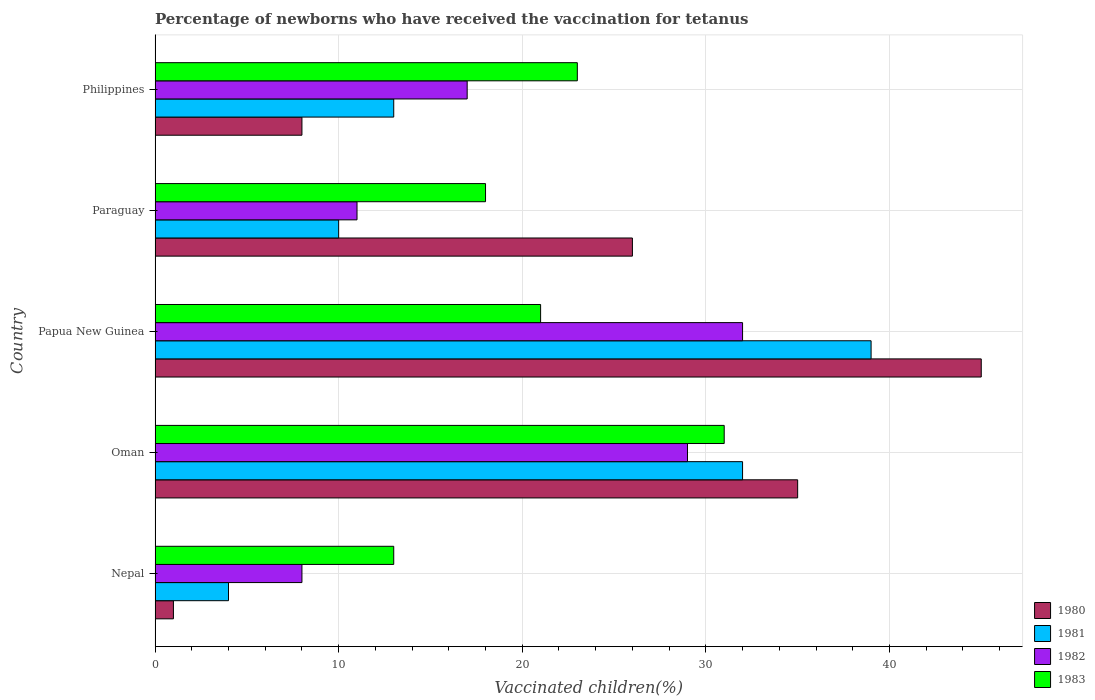How many different coloured bars are there?
Your response must be concise. 4. How many groups of bars are there?
Keep it short and to the point. 5. Are the number of bars per tick equal to the number of legend labels?
Offer a very short reply. Yes. How many bars are there on the 4th tick from the top?
Make the answer very short. 4. How many bars are there on the 3rd tick from the bottom?
Your answer should be very brief. 4. What is the label of the 4th group of bars from the top?
Give a very brief answer. Oman. Across all countries, what is the maximum percentage of vaccinated children in 1980?
Your answer should be compact. 45. In which country was the percentage of vaccinated children in 1982 maximum?
Offer a very short reply. Papua New Guinea. In which country was the percentage of vaccinated children in 1980 minimum?
Ensure brevity in your answer.  Nepal. What is the total percentage of vaccinated children in 1981 in the graph?
Offer a terse response. 98. What is the difference between the percentage of vaccinated children in 1980 in Paraguay and the percentage of vaccinated children in 1982 in Philippines?
Provide a succinct answer. 9. What is the average percentage of vaccinated children in 1980 per country?
Keep it short and to the point. 23. In how many countries, is the percentage of vaccinated children in 1983 greater than 32 %?
Your response must be concise. 0. Is the percentage of vaccinated children in 1980 in Papua New Guinea less than that in Paraguay?
Your answer should be compact. No. Is the difference between the percentage of vaccinated children in 1983 in Oman and Paraguay greater than the difference between the percentage of vaccinated children in 1981 in Oman and Paraguay?
Make the answer very short. No. In how many countries, is the percentage of vaccinated children in 1980 greater than the average percentage of vaccinated children in 1980 taken over all countries?
Provide a succinct answer. 3. Is the sum of the percentage of vaccinated children in 1982 in Nepal and Papua New Guinea greater than the maximum percentage of vaccinated children in 1980 across all countries?
Your answer should be compact. No. Is it the case that in every country, the sum of the percentage of vaccinated children in 1982 and percentage of vaccinated children in 1980 is greater than the sum of percentage of vaccinated children in 1983 and percentage of vaccinated children in 1981?
Your answer should be compact. No. What does the 4th bar from the top in Nepal represents?
Provide a succinct answer. 1980. How many bars are there?
Offer a terse response. 20. How many countries are there in the graph?
Provide a succinct answer. 5. What is the difference between two consecutive major ticks on the X-axis?
Give a very brief answer. 10. Does the graph contain grids?
Make the answer very short. Yes. Where does the legend appear in the graph?
Make the answer very short. Bottom right. What is the title of the graph?
Your answer should be compact. Percentage of newborns who have received the vaccination for tetanus. What is the label or title of the X-axis?
Your response must be concise. Vaccinated children(%). What is the Vaccinated children(%) in 1981 in Nepal?
Offer a very short reply. 4. What is the Vaccinated children(%) of 1982 in Nepal?
Give a very brief answer. 8. What is the Vaccinated children(%) in 1980 in Oman?
Your response must be concise. 35. What is the Vaccinated children(%) in 1982 in Oman?
Your response must be concise. 29. What is the Vaccinated children(%) of 1983 in Oman?
Your response must be concise. 31. What is the Vaccinated children(%) in 1980 in Papua New Guinea?
Your answer should be very brief. 45. What is the Vaccinated children(%) in 1983 in Papua New Guinea?
Provide a succinct answer. 21. What is the Vaccinated children(%) in 1980 in Paraguay?
Give a very brief answer. 26. What is the Vaccinated children(%) of 1982 in Paraguay?
Ensure brevity in your answer.  11. What is the Vaccinated children(%) of 1983 in Paraguay?
Give a very brief answer. 18. What is the Vaccinated children(%) in 1981 in Philippines?
Your answer should be very brief. 13. Across all countries, what is the maximum Vaccinated children(%) of 1980?
Offer a very short reply. 45. Across all countries, what is the maximum Vaccinated children(%) of 1981?
Your answer should be compact. 39. Across all countries, what is the maximum Vaccinated children(%) of 1982?
Keep it short and to the point. 32. Across all countries, what is the maximum Vaccinated children(%) in 1983?
Offer a terse response. 31. Across all countries, what is the minimum Vaccinated children(%) in 1981?
Keep it short and to the point. 4. Across all countries, what is the minimum Vaccinated children(%) in 1983?
Provide a succinct answer. 13. What is the total Vaccinated children(%) of 1980 in the graph?
Offer a very short reply. 115. What is the total Vaccinated children(%) in 1981 in the graph?
Provide a short and direct response. 98. What is the total Vaccinated children(%) in 1982 in the graph?
Provide a succinct answer. 97. What is the total Vaccinated children(%) in 1983 in the graph?
Your answer should be very brief. 106. What is the difference between the Vaccinated children(%) in 1980 in Nepal and that in Oman?
Offer a very short reply. -34. What is the difference between the Vaccinated children(%) of 1981 in Nepal and that in Oman?
Your answer should be very brief. -28. What is the difference between the Vaccinated children(%) in 1980 in Nepal and that in Papua New Guinea?
Your response must be concise. -44. What is the difference between the Vaccinated children(%) in 1981 in Nepal and that in Papua New Guinea?
Provide a succinct answer. -35. What is the difference between the Vaccinated children(%) in 1981 in Nepal and that in Paraguay?
Keep it short and to the point. -6. What is the difference between the Vaccinated children(%) of 1980 in Nepal and that in Philippines?
Make the answer very short. -7. What is the difference between the Vaccinated children(%) in 1981 in Nepal and that in Philippines?
Offer a terse response. -9. What is the difference between the Vaccinated children(%) in 1982 in Nepal and that in Philippines?
Offer a very short reply. -9. What is the difference between the Vaccinated children(%) in 1983 in Nepal and that in Philippines?
Your answer should be compact. -10. What is the difference between the Vaccinated children(%) of 1980 in Oman and that in Papua New Guinea?
Provide a short and direct response. -10. What is the difference between the Vaccinated children(%) of 1981 in Oman and that in Paraguay?
Keep it short and to the point. 22. What is the difference between the Vaccinated children(%) of 1982 in Oman and that in Paraguay?
Provide a succinct answer. 18. What is the difference between the Vaccinated children(%) in 1983 in Oman and that in Philippines?
Your answer should be very brief. 8. What is the difference between the Vaccinated children(%) of 1983 in Papua New Guinea and that in Paraguay?
Offer a terse response. 3. What is the difference between the Vaccinated children(%) of 1982 in Papua New Guinea and that in Philippines?
Your response must be concise. 15. What is the difference between the Vaccinated children(%) of 1982 in Paraguay and that in Philippines?
Your response must be concise. -6. What is the difference between the Vaccinated children(%) of 1983 in Paraguay and that in Philippines?
Your response must be concise. -5. What is the difference between the Vaccinated children(%) in 1980 in Nepal and the Vaccinated children(%) in 1981 in Oman?
Provide a short and direct response. -31. What is the difference between the Vaccinated children(%) in 1980 in Nepal and the Vaccinated children(%) in 1982 in Oman?
Give a very brief answer. -28. What is the difference between the Vaccinated children(%) of 1980 in Nepal and the Vaccinated children(%) of 1981 in Papua New Guinea?
Make the answer very short. -38. What is the difference between the Vaccinated children(%) of 1980 in Nepal and the Vaccinated children(%) of 1982 in Papua New Guinea?
Your response must be concise. -31. What is the difference between the Vaccinated children(%) of 1980 in Nepal and the Vaccinated children(%) of 1983 in Papua New Guinea?
Your response must be concise. -20. What is the difference between the Vaccinated children(%) in 1981 in Nepal and the Vaccinated children(%) in 1983 in Papua New Guinea?
Keep it short and to the point. -17. What is the difference between the Vaccinated children(%) of 1982 in Nepal and the Vaccinated children(%) of 1983 in Papua New Guinea?
Your answer should be compact. -13. What is the difference between the Vaccinated children(%) in 1980 in Nepal and the Vaccinated children(%) in 1983 in Paraguay?
Provide a short and direct response. -17. What is the difference between the Vaccinated children(%) in 1981 in Nepal and the Vaccinated children(%) in 1982 in Paraguay?
Your response must be concise. -7. What is the difference between the Vaccinated children(%) in 1981 in Nepal and the Vaccinated children(%) in 1983 in Paraguay?
Keep it short and to the point. -14. What is the difference between the Vaccinated children(%) of 1980 in Nepal and the Vaccinated children(%) of 1981 in Philippines?
Keep it short and to the point. -12. What is the difference between the Vaccinated children(%) of 1980 in Nepal and the Vaccinated children(%) of 1982 in Philippines?
Make the answer very short. -16. What is the difference between the Vaccinated children(%) in 1980 in Oman and the Vaccinated children(%) in 1981 in Papua New Guinea?
Give a very brief answer. -4. What is the difference between the Vaccinated children(%) in 1980 in Oman and the Vaccinated children(%) in 1982 in Papua New Guinea?
Make the answer very short. 3. What is the difference between the Vaccinated children(%) of 1980 in Oman and the Vaccinated children(%) of 1983 in Papua New Guinea?
Ensure brevity in your answer.  14. What is the difference between the Vaccinated children(%) in 1981 in Oman and the Vaccinated children(%) in 1983 in Papua New Guinea?
Your answer should be compact. 11. What is the difference between the Vaccinated children(%) of 1982 in Oman and the Vaccinated children(%) of 1983 in Papua New Guinea?
Make the answer very short. 8. What is the difference between the Vaccinated children(%) in 1981 in Oman and the Vaccinated children(%) in 1983 in Paraguay?
Offer a very short reply. 14. What is the difference between the Vaccinated children(%) in 1982 in Oman and the Vaccinated children(%) in 1983 in Paraguay?
Provide a succinct answer. 11. What is the difference between the Vaccinated children(%) of 1980 in Oman and the Vaccinated children(%) of 1981 in Philippines?
Your answer should be very brief. 22. What is the difference between the Vaccinated children(%) of 1980 in Oman and the Vaccinated children(%) of 1982 in Philippines?
Your answer should be very brief. 18. What is the difference between the Vaccinated children(%) in 1980 in Oman and the Vaccinated children(%) in 1983 in Philippines?
Offer a very short reply. 12. What is the difference between the Vaccinated children(%) in 1981 in Oman and the Vaccinated children(%) in 1982 in Philippines?
Provide a succinct answer. 15. What is the difference between the Vaccinated children(%) of 1982 in Oman and the Vaccinated children(%) of 1983 in Philippines?
Make the answer very short. 6. What is the difference between the Vaccinated children(%) in 1980 in Papua New Guinea and the Vaccinated children(%) in 1982 in Paraguay?
Provide a succinct answer. 34. What is the difference between the Vaccinated children(%) in 1980 in Papua New Guinea and the Vaccinated children(%) in 1983 in Paraguay?
Provide a short and direct response. 27. What is the difference between the Vaccinated children(%) in 1981 in Papua New Guinea and the Vaccinated children(%) in 1983 in Paraguay?
Your answer should be compact. 21. What is the difference between the Vaccinated children(%) in 1980 in Papua New Guinea and the Vaccinated children(%) in 1983 in Philippines?
Your answer should be very brief. 22. What is the difference between the Vaccinated children(%) of 1981 in Papua New Guinea and the Vaccinated children(%) of 1982 in Philippines?
Give a very brief answer. 22. What is the difference between the Vaccinated children(%) in 1982 in Papua New Guinea and the Vaccinated children(%) in 1983 in Philippines?
Your response must be concise. 9. What is the difference between the Vaccinated children(%) in 1980 in Paraguay and the Vaccinated children(%) in 1982 in Philippines?
Provide a short and direct response. 9. What is the difference between the Vaccinated children(%) of 1980 in Paraguay and the Vaccinated children(%) of 1983 in Philippines?
Your answer should be compact. 3. What is the difference between the Vaccinated children(%) in 1981 in Paraguay and the Vaccinated children(%) in 1982 in Philippines?
Your answer should be compact. -7. What is the difference between the Vaccinated children(%) in 1981 in Paraguay and the Vaccinated children(%) in 1983 in Philippines?
Your answer should be very brief. -13. What is the difference between the Vaccinated children(%) of 1982 in Paraguay and the Vaccinated children(%) of 1983 in Philippines?
Keep it short and to the point. -12. What is the average Vaccinated children(%) of 1980 per country?
Provide a succinct answer. 23. What is the average Vaccinated children(%) of 1981 per country?
Ensure brevity in your answer.  19.6. What is the average Vaccinated children(%) in 1983 per country?
Ensure brevity in your answer.  21.2. What is the difference between the Vaccinated children(%) in 1980 and Vaccinated children(%) in 1982 in Nepal?
Your response must be concise. -7. What is the difference between the Vaccinated children(%) in 1980 and Vaccinated children(%) in 1983 in Nepal?
Your response must be concise. -12. What is the difference between the Vaccinated children(%) of 1980 and Vaccinated children(%) of 1983 in Oman?
Your answer should be very brief. 4. What is the difference between the Vaccinated children(%) in 1981 and Vaccinated children(%) in 1982 in Oman?
Offer a very short reply. 3. What is the difference between the Vaccinated children(%) in 1981 and Vaccinated children(%) in 1983 in Oman?
Ensure brevity in your answer.  1. What is the difference between the Vaccinated children(%) of 1982 and Vaccinated children(%) of 1983 in Oman?
Offer a very short reply. -2. What is the difference between the Vaccinated children(%) in 1981 and Vaccinated children(%) in 1982 in Papua New Guinea?
Keep it short and to the point. 7. What is the difference between the Vaccinated children(%) of 1981 and Vaccinated children(%) of 1983 in Papua New Guinea?
Keep it short and to the point. 18. What is the difference between the Vaccinated children(%) of 1982 and Vaccinated children(%) of 1983 in Papua New Guinea?
Offer a terse response. 11. What is the difference between the Vaccinated children(%) of 1980 and Vaccinated children(%) of 1981 in Paraguay?
Your answer should be compact. 16. What is the difference between the Vaccinated children(%) in 1981 and Vaccinated children(%) in 1983 in Paraguay?
Offer a terse response. -8. What is the difference between the Vaccinated children(%) in 1982 and Vaccinated children(%) in 1983 in Paraguay?
Your response must be concise. -7. What is the difference between the Vaccinated children(%) of 1980 and Vaccinated children(%) of 1981 in Philippines?
Provide a succinct answer. -5. What is the difference between the Vaccinated children(%) in 1980 and Vaccinated children(%) in 1983 in Philippines?
Provide a short and direct response. -15. What is the difference between the Vaccinated children(%) of 1981 and Vaccinated children(%) of 1983 in Philippines?
Offer a terse response. -10. What is the ratio of the Vaccinated children(%) of 1980 in Nepal to that in Oman?
Make the answer very short. 0.03. What is the ratio of the Vaccinated children(%) of 1982 in Nepal to that in Oman?
Keep it short and to the point. 0.28. What is the ratio of the Vaccinated children(%) of 1983 in Nepal to that in Oman?
Ensure brevity in your answer.  0.42. What is the ratio of the Vaccinated children(%) of 1980 in Nepal to that in Papua New Guinea?
Your answer should be very brief. 0.02. What is the ratio of the Vaccinated children(%) in 1981 in Nepal to that in Papua New Guinea?
Ensure brevity in your answer.  0.1. What is the ratio of the Vaccinated children(%) of 1982 in Nepal to that in Papua New Guinea?
Ensure brevity in your answer.  0.25. What is the ratio of the Vaccinated children(%) in 1983 in Nepal to that in Papua New Guinea?
Your answer should be very brief. 0.62. What is the ratio of the Vaccinated children(%) in 1980 in Nepal to that in Paraguay?
Give a very brief answer. 0.04. What is the ratio of the Vaccinated children(%) in 1982 in Nepal to that in Paraguay?
Give a very brief answer. 0.73. What is the ratio of the Vaccinated children(%) in 1983 in Nepal to that in Paraguay?
Provide a short and direct response. 0.72. What is the ratio of the Vaccinated children(%) of 1981 in Nepal to that in Philippines?
Your answer should be compact. 0.31. What is the ratio of the Vaccinated children(%) in 1982 in Nepal to that in Philippines?
Offer a very short reply. 0.47. What is the ratio of the Vaccinated children(%) in 1983 in Nepal to that in Philippines?
Provide a short and direct response. 0.57. What is the ratio of the Vaccinated children(%) of 1981 in Oman to that in Papua New Guinea?
Give a very brief answer. 0.82. What is the ratio of the Vaccinated children(%) in 1982 in Oman to that in Papua New Guinea?
Offer a terse response. 0.91. What is the ratio of the Vaccinated children(%) in 1983 in Oman to that in Papua New Guinea?
Offer a very short reply. 1.48. What is the ratio of the Vaccinated children(%) of 1980 in Oman to that in Paraguay?
Provide a succinct answer. 1.35. What is the ratio of the Vaccinated children(%) in 1982 in Oman to that in Paraguay?
Ensure brevity in your answer.  2.64. What is the ratio of the Vaccinated children(%) in 1983 in Oman to that in Paraguay?
Keep it short and to the point. 1.72. What is the ratio of the Vaccinated children(%) in 1980 in Oman to that in Philippines?
Offer a very short reply. 4.38. What is the ratio of the Vaccinated children(%) in 1981 in Oman to that in Philippines?
Ensure brevity in your answer.  2.46. What is the ratio of the Vaccinated children(%) of 1982 in Oman to that in Philippines?
Keep it short and to the point. 1.71. What is the ratio of the Vaccinated children(%) in 1983 in Oman to that in Philippines?
Make the answer very short. 1.35. What is the ratio of the Vaccinated children(%) in 1980 in Papua New Guinea to that in Paraguay?
Make the answer very short. 1.73. What is the ratio of the Vaccinated children(%) in 1981 in Papua New Guinea to that in Paraguay?
Your response must be concise. 3.9. What is the ratio of the Vaccinated children(%) in 1982 in Papua New Guinea to that in Paraguay?
Keep it short and to the point. 2.91. What is the ratio of the Vaccinated children(%) of 1980 in Papua New Guinea to that in Philippines?
Your answer should be compact. 5.62. What is the ratio of the Vaccinated children(%) in 1982 in Papua New Guinea to that in Philippines?
Keep it short and to the point. 1.88. What is the ratio of the Vaccinated children(%) in 1983 in Papua New Guinea to that in Philippines?
Your response must be concise. 0.91. What is the ratio of the Vaccinated children(%) in 1981 in Paraguay to that in Philippines?
Your answer should be very brief. 0.77. What is the ratio of the Vaccinated children(%) in 1982 in Paraguay to that in Philippines?
Provide a short and direct response. 0.65. What is the ratio of the Vaccinated children(%) of 1983 in Paraguay to that in Philippines?
Your response must be concise. 0.78. What is the difference between the highest and the second highest Vaccinated children(%) of 1980?
Provide a succinct answer. 10. What is the difference between the highest and the second highest Vaccinated children(%) of 1983?
Provide a short and direct response. 8. 